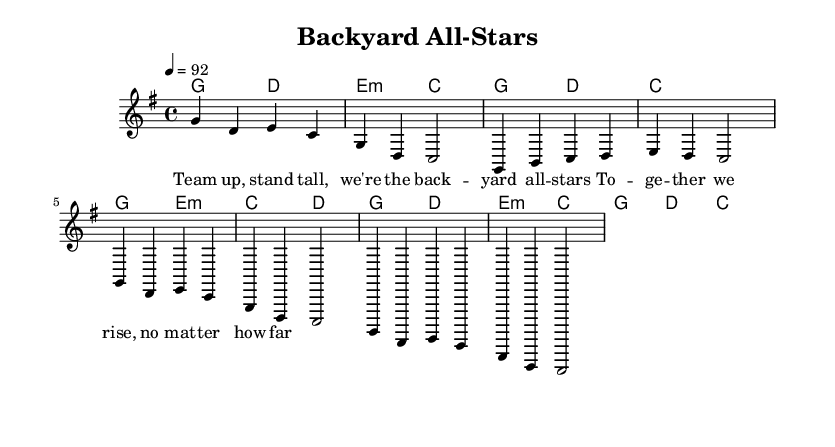What is the key signature of this music? The key signature is G major, indicated by the one sharp (F#) present throughout the piece.
Answer: G major What is the time signature of this music? The time signature is 4/4, as indicated at the beginning of the score, which means there are four beats in a measure and the quarter note gets one beat.
Answer: 4/4 What is the tempo marking in this music? The tempo marking is 92, specified by the indication "4 = 92", meaning there are 92 beats per minute.
Answer: 92 How many measures are there in the chorus section? The chorus section contains four measures, identifiable by counting the sections of the melody labeled as "Chorus" in the score.
Answer: Four What is the primary lyrical theme in the song? The primary lyrical theme is teamwork and camaraderie, as highlighted by the lyrics, which convey a message of unity and support among individuals.
Answer: Teamwork How does the harmony change from the verse to the chorus? The harmony shows a shift from g2 e:m and c d in the verse to g2 d and e:m c in the chorus, emphasizing a return to the motif of togetherness through familiar chords.
Answer: Shift in harmony Which section features repeated lyrics? The chorus features repeated lyrics, specifically the lines about standing tall and rising together, emphasizing the collective spirit.
Answer: Chorus 